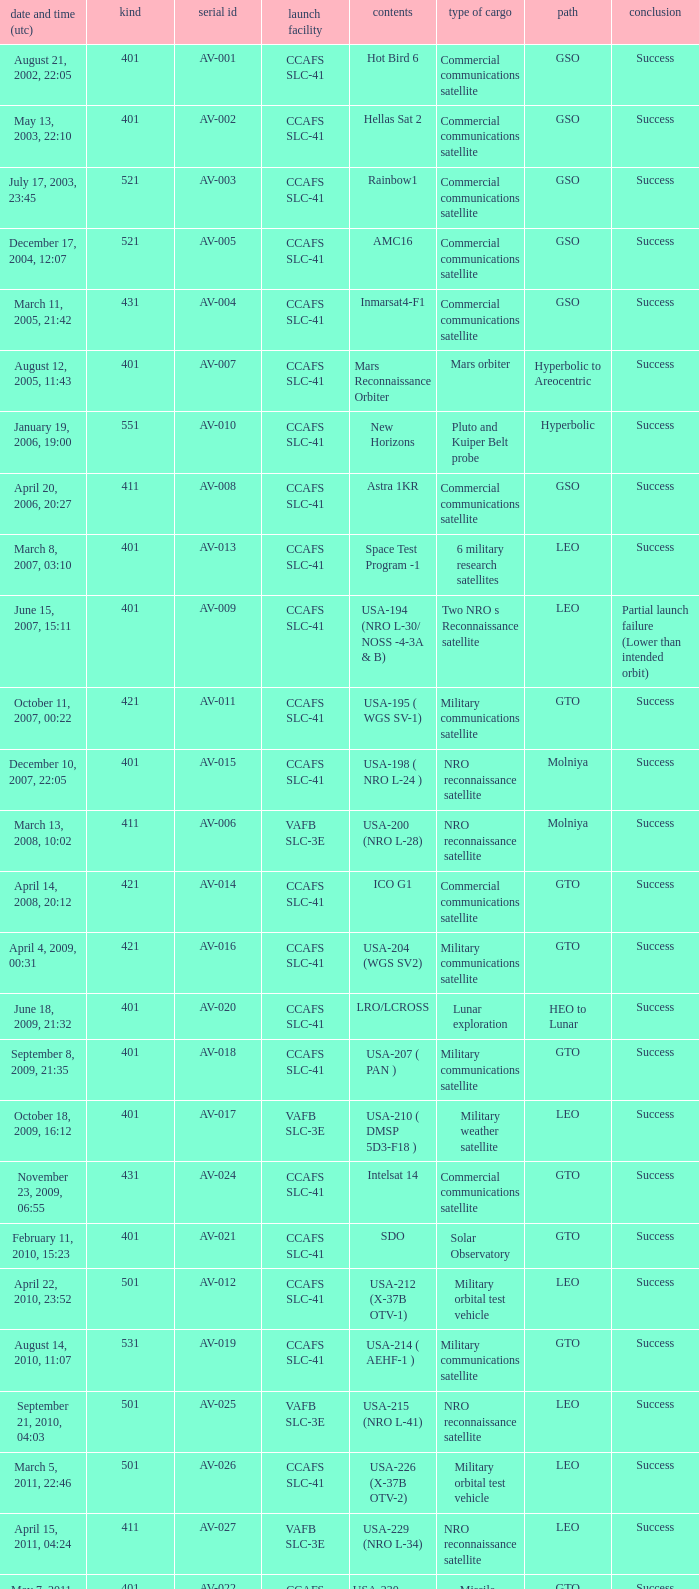What payload was on November 26, 2011, 15:02? Mars rover. 